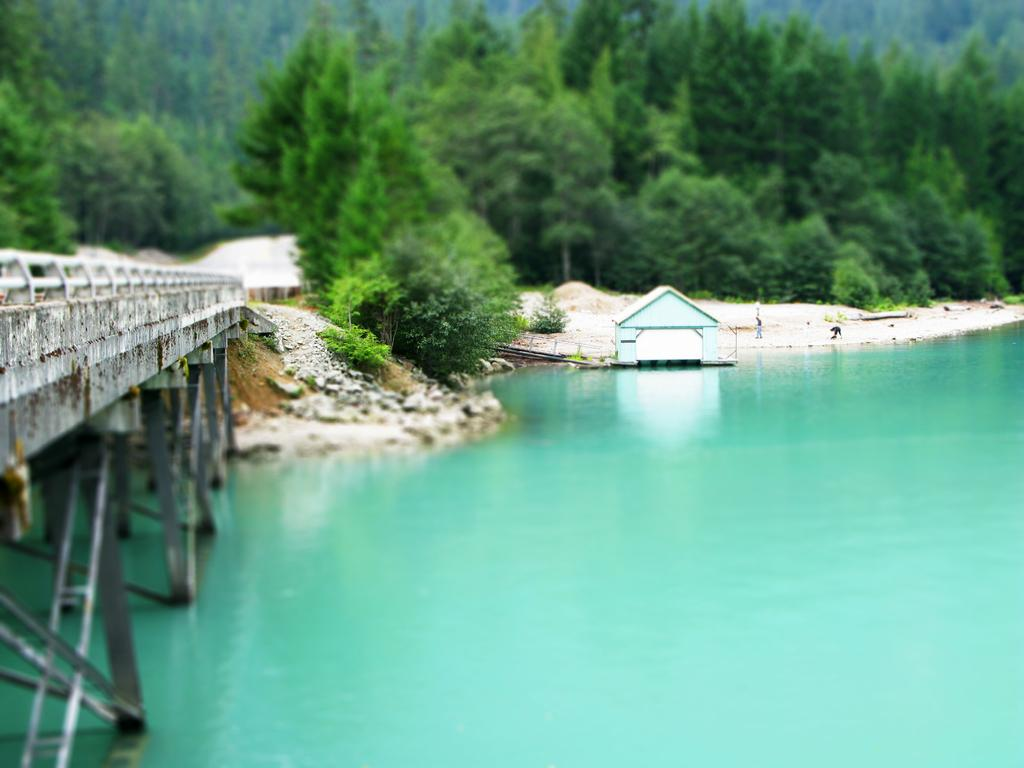What is the main feature of the image? The main feature of the image is water. What structure can be seen crossing over the water? There is: There is a bridge in the image. What is floating or placed on the water? There is an object on the water. What type of terrain is visible near the water? There is sand visible in the image. What can be seen in the background of the image? There are trees in the background of the image. What type of wheel can be seen on the object in the image? There is no wheel present on the object in the image. Can you describe the process of the object biting into the water? The object does not bite into the water; it is simply floating or placed on the water's surface. 